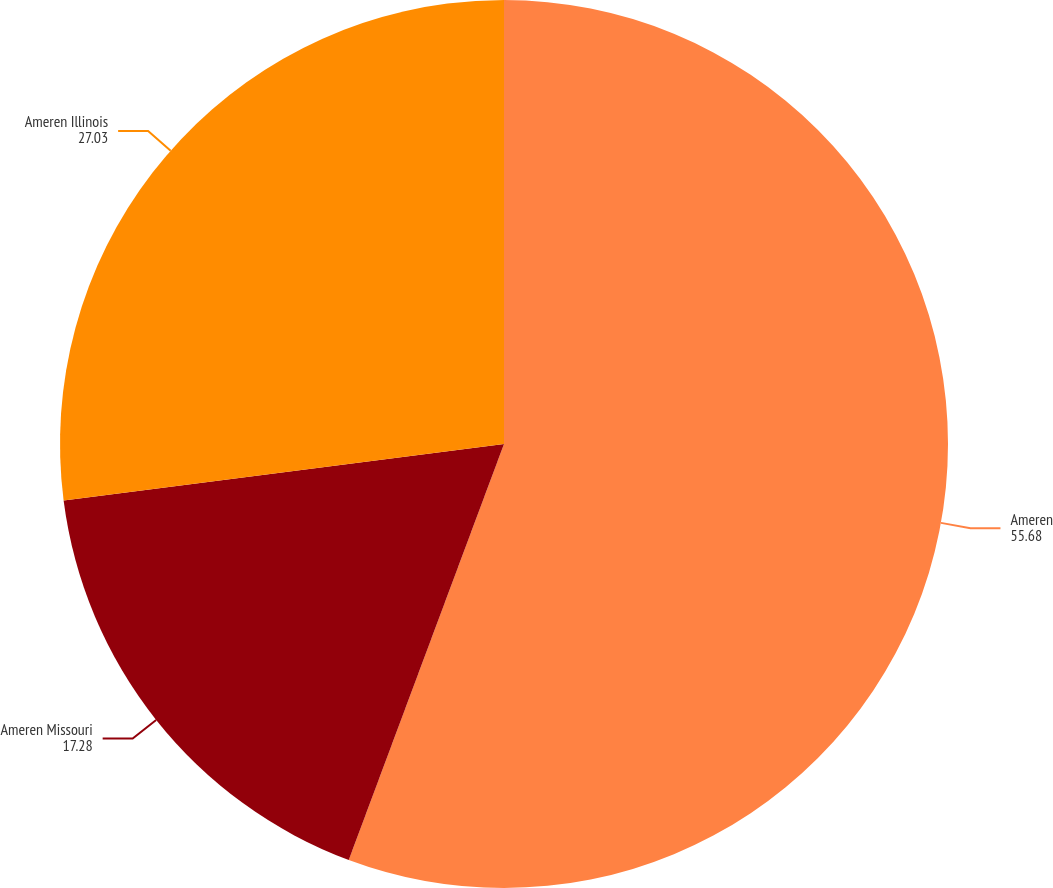Convert chart to OTSL. <chart><loc_0><loc_0><loc_500><loc_500><pie_chart><fcel>Ameren<fcel>Ameren Missouri<fcel>Ameren Illinois<nl><fcel>55.68%<fcel>17.28%<fcel>27.03%<nl></chart> 